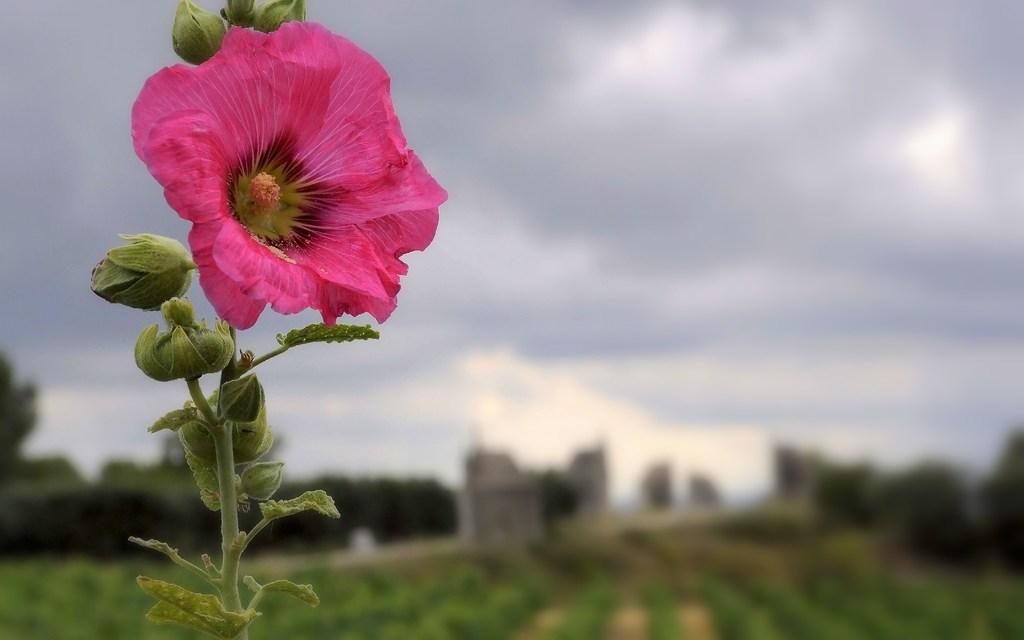What is the main subject of the image? There is a flower in the image. Are there any other parts of the plant visible besides the flower? Yes, there are buds of a plant in the image. What can be observed about the background of the image? The background of the image is blurred. What is visible in the background beyond the blurred area? The sky is visible in the background of the image. Can you hear the bell ringing in the image? There is no bell present in the image, so it cannot be heard. 